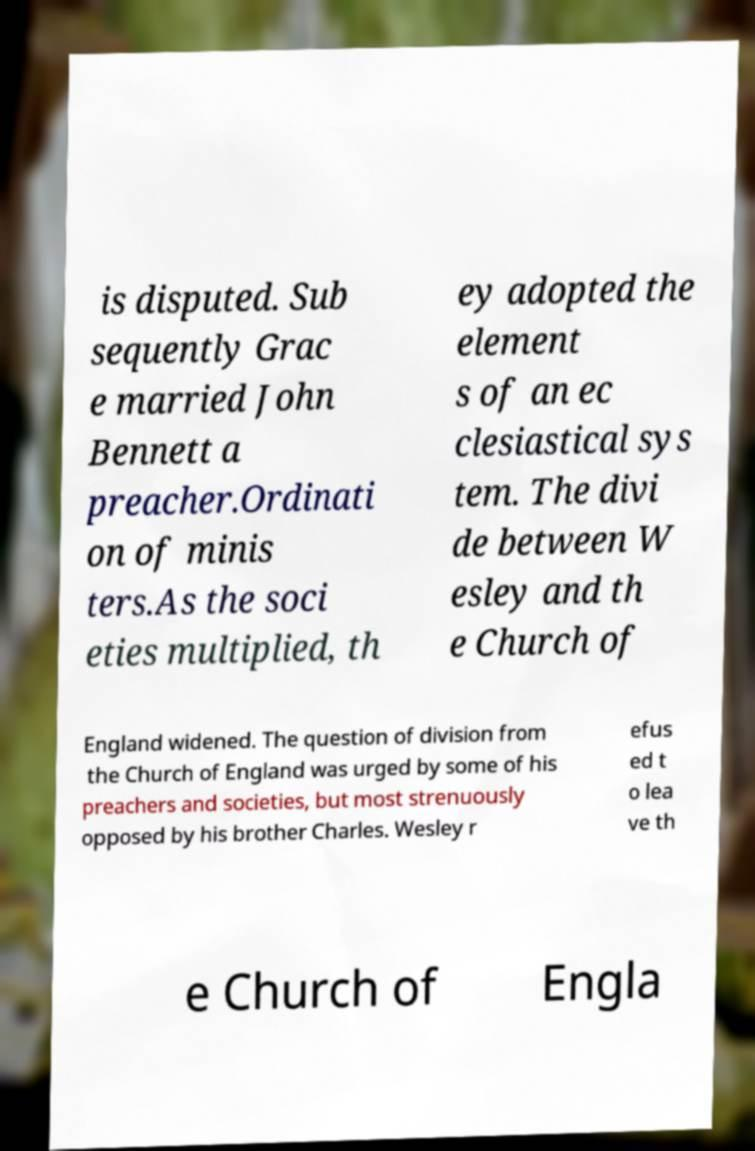Can you read and provide the text displayed in the image?This photo seems to have some interesting text. Can you extract and type it out for me? is disputed. Sub sequently Grac e married John Bennett a preacher.Ordinati on of minis ters.As the soci eties multiplied, th ey adopted the element s of an ec clesiastical sys tem. The divi de between W esley and th e Church of England widened. The question of division from the Church of England was urged by some of his preachers and societies, but most strenuously opposed by his brother Charles. Wesley r efus ed t o lea ve th e Church of Engla 